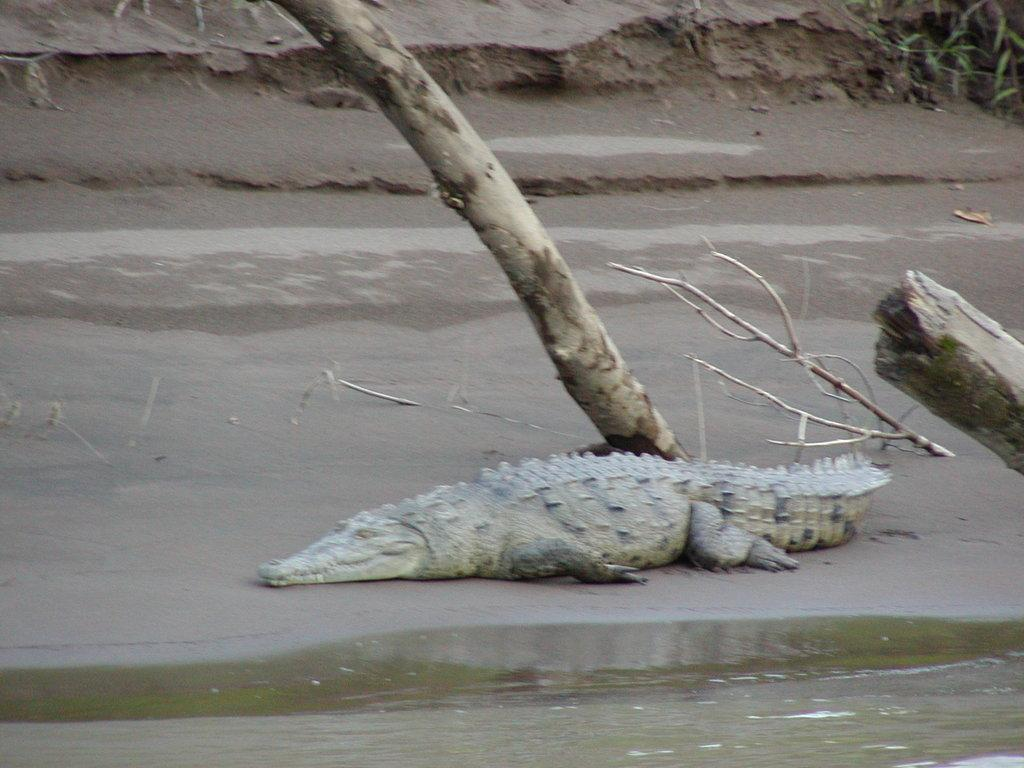What animal can be seen on the ground in the image? There is a crocodile on the ground in the image. What type of objects are made of wood in the image? There are wooden objects in the image. What type of plant is present in the image? There is a plant in the image. What natural element is visible in the image? There is water visible in the image. What type of bone can be seen in the image? There is no bone present in the image. What is the length of the crocodile's tail in the image? The length of the crocodile's tail cannot be determined from the image alone, as it is not a measurable detail. 